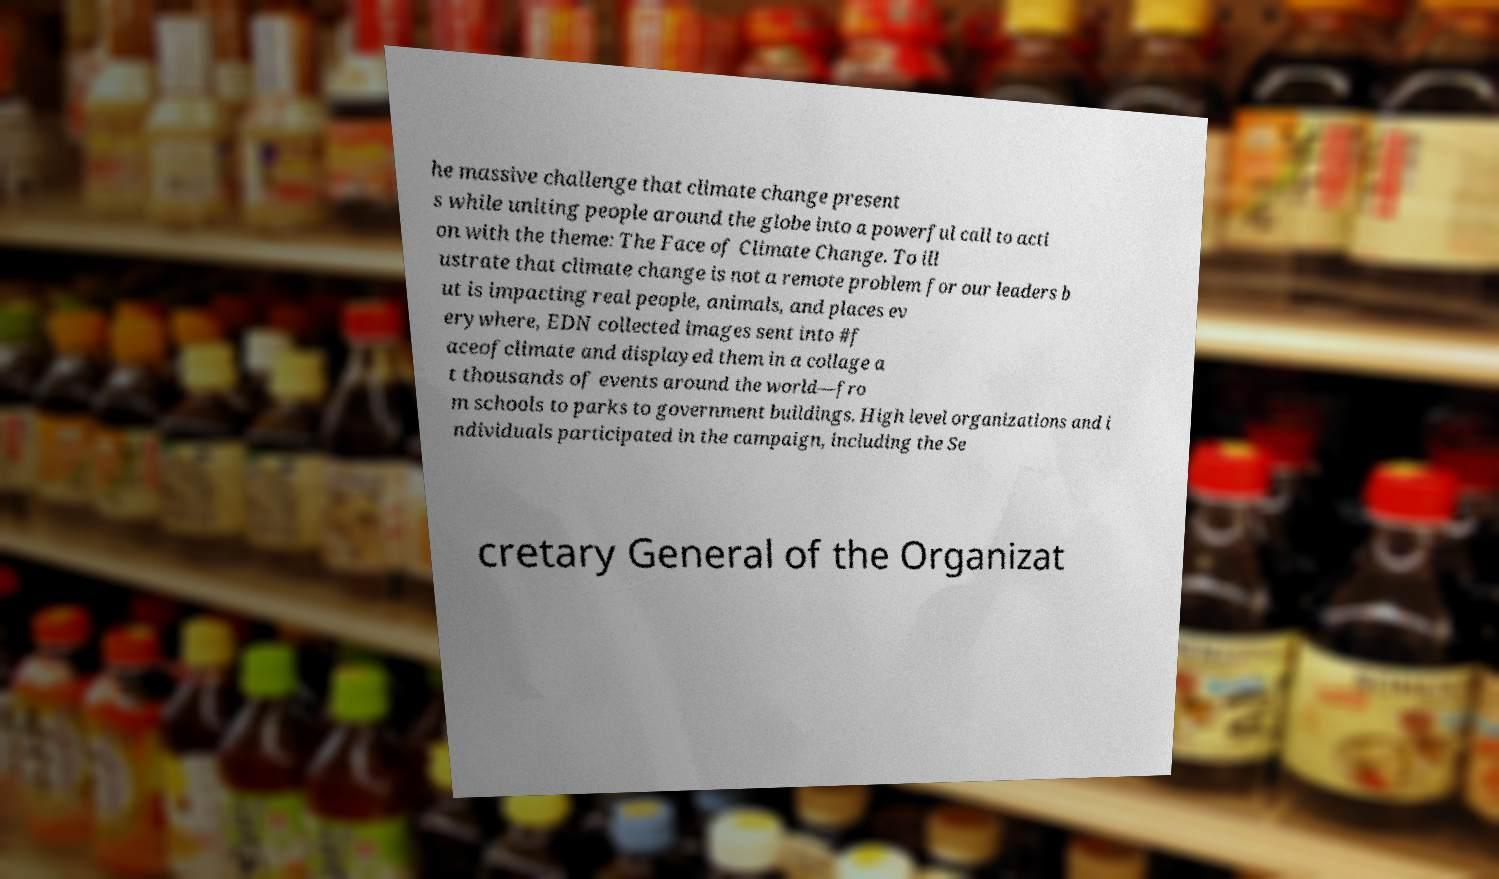There's text embedded in this image that I need extracted. Can you transcribe it verbatim? he massive challenge that climate change present s while uniting people around the globe into a powerful call to acti on with the theme: The Face of Climate Change. To ill ustrate that climate change is not a remote problem for our leaders b ut is impacting real people, animals, and places ev erywhere, EDN collected images sent into #f aceofclimate and displayed them in a collage a t thousands of events around the world—fro m schools to parks to government buildings. High level organizations and i ndividuals participated in the campaign, including the Se cretary General of the Organizat 